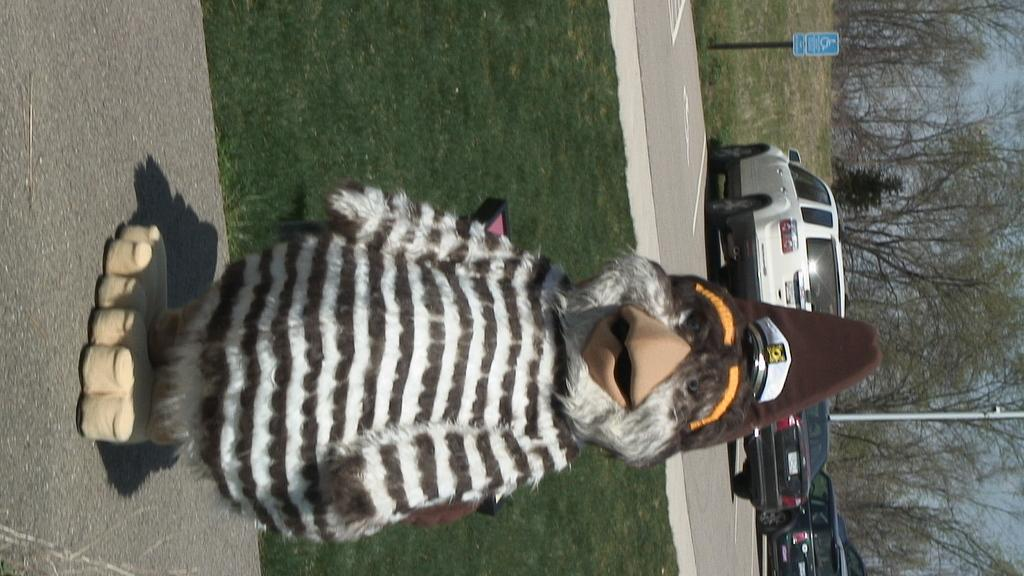What is the main subject on the road in the image? There is a mascot on the road in the image. What type of vegetation can be seen in the image? There is grass visible in the image, as well as trees. What type of vehicles are present in the image? Cars are present in the image. What structures can be seen in the image? Poles are visible in the image. What is the purpose of the board in the image? The purpose of the board in the image is not specified, but it could be for advertising or displaying information. What is visible in the background of the image? The sky is visible in the background of the image. How many tomatoes are hanging from the mascot's hat in the image? There are no tomatoes present in the image, nor are they hanging from the mascot's hat. 